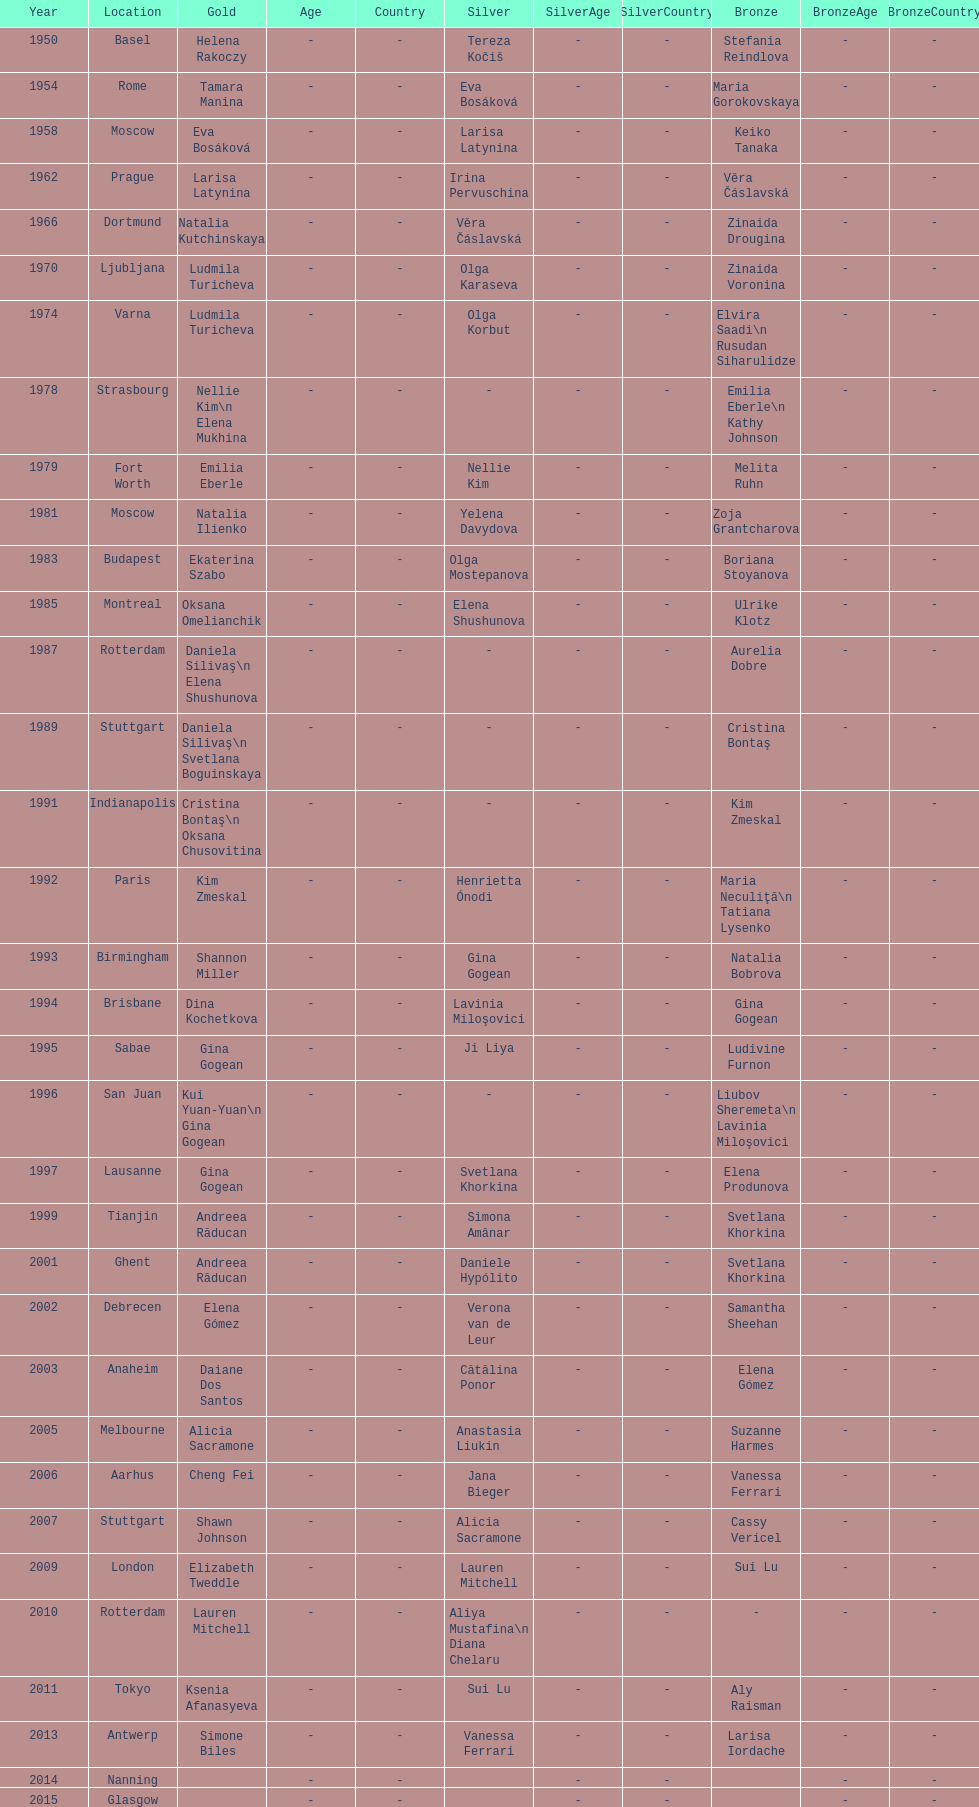How many times was the location in the united states? 3. 